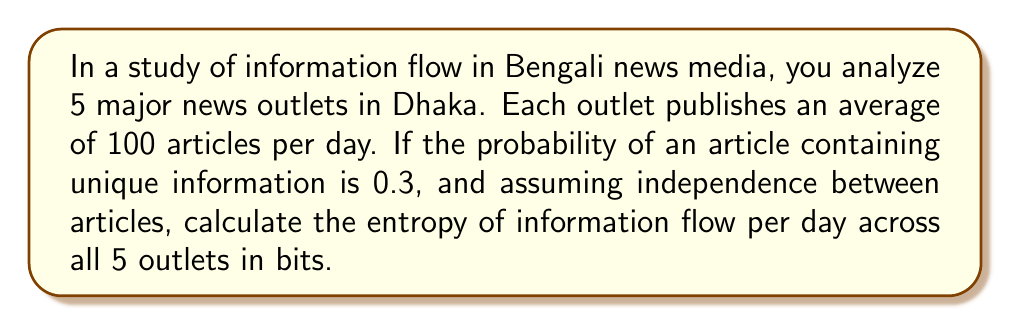Could you help me with this problem? To solve this problem, we'll use the concept of information entropy from statistical mechanics. Let's approach this step-by-step:

1) First, we need to understand what our system is:
   - 5 news outlets
   - Each publishes 100 articles per day
   - Probability of unique information in an article is 0.3

2) In information theory, entropy is calculated using the formula:

   $$ H = -\sum_{i=1}^{n} p_i \log_2(p_i) $$

   where $p_i$ is the probability of each possible outcome.

3) In our case, we have two possible outcomes for each article:
   - Unique information (probability = 0.3)
   - Non-unique information (probability = 1 - 0.3 = 0.7)

4) Let's calculate the entropy for a single article:

   $$ H_{article} = -(0.3 \log_2(0.3) + 0.7 \log_2(0.7)) $$
   $$ H_{article} \approx 0.8813 \text{ bits} $$

5) Now, we need to consider all articles across all outlets:
   - Total number of articles = 5 outlets × 100 articles = 500 articles

6) Assuming independence between articles, the total entropy is the sum of entropies of individual articles:

   $$ H_{total} = 500 \times 0.8813 \approx 440.65 \text{ bits} $$

This represents the average amount of information conveyed by the system per day.
Answer: 440.65 bits 